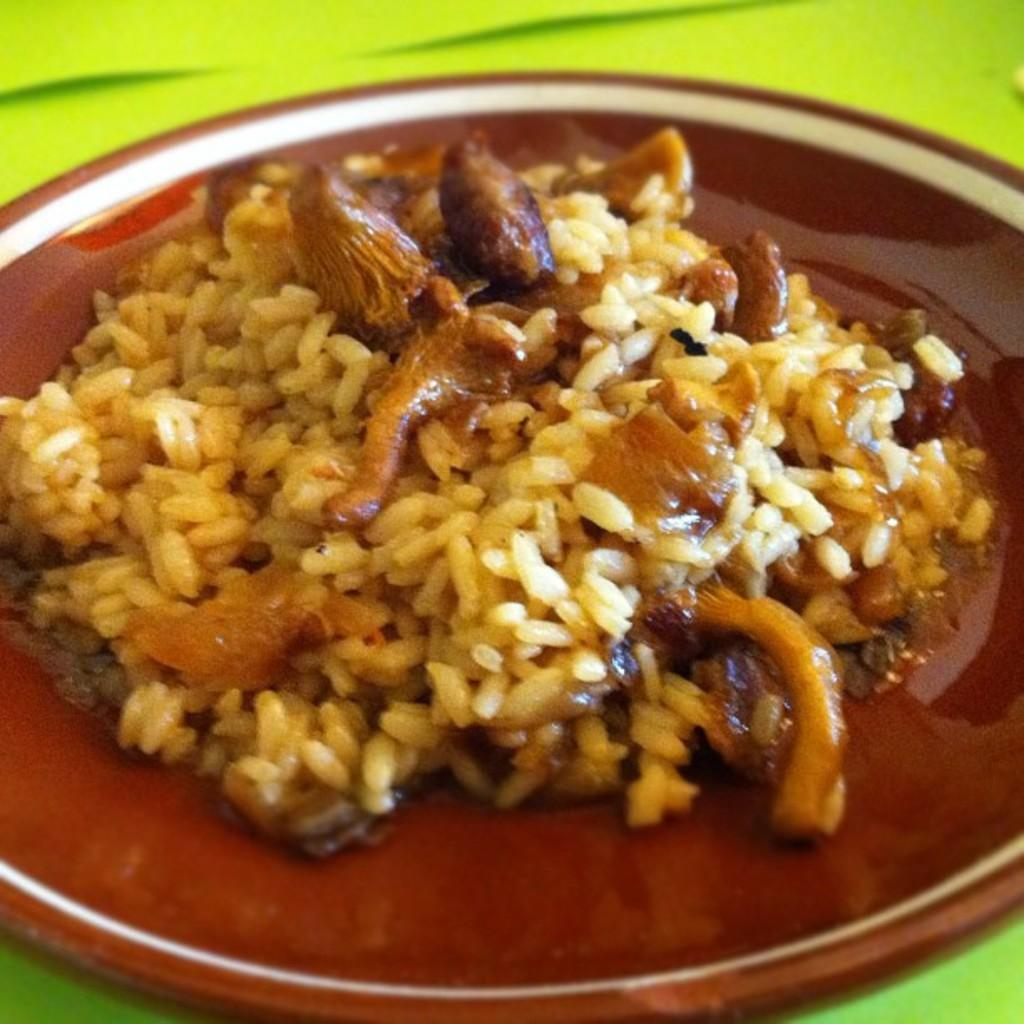What is on the plate that is visible in the image? There are food items on a plate in the image. Where is the plate located in the image? The plate is placed on a table in the image. Can you describe the setting where the plate is located? The image may have been taken in a room, as there is a table present. What type of fruit can be seen growing on the seashore in the image? There is no seashore or fruit present in the image; it features a plate of food items on a table. 